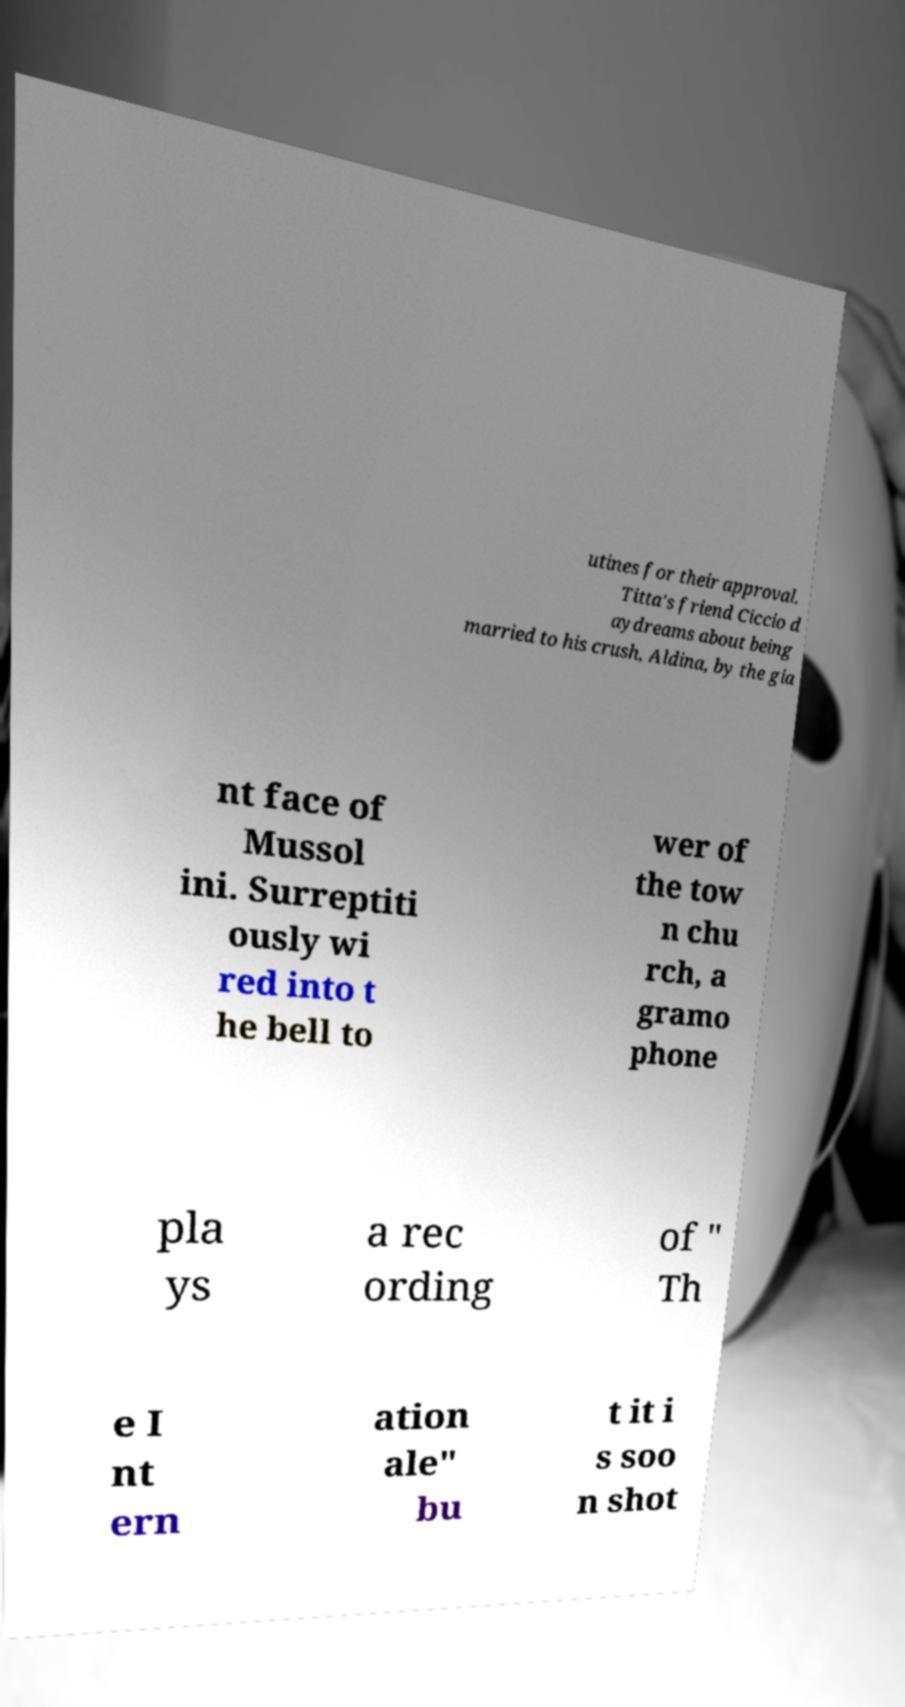What messages or text are displayed in this image? I need them in a readable, typed format. utines for their approval. Titta's friend Ciccio d aydreams about being married to his crush, Aldina, by the gia nt face of Mussol ini. Surreptiti ously wi red into t he bell to wer of the tow n chu rch, a gramo phone pla ys a rec ording of " Th e I nt ern ation ale" bu t it i s soo n shot 